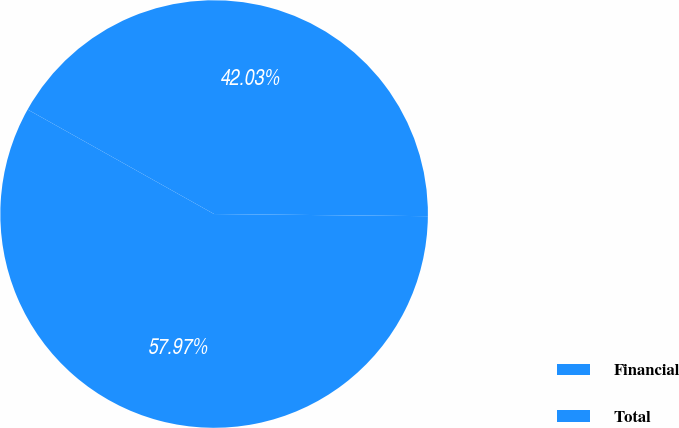<chart> <loc_0><loc_0><loc_500><loc_500><pie_chart><fcel>Financial<fcel>Total<nl><fcel>42.03%<fcel>57.97%<nl></chart> 